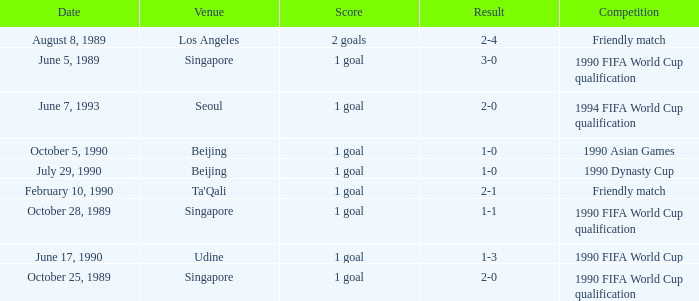What was the score of the match with a 3-0 result? 1 goal. 